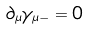Convert formula to latex. <formula><loc_0><loc_0><loc_500><loc_500>\partial _ { \mu } \gamma _ { \mu - } = 0</formula> 